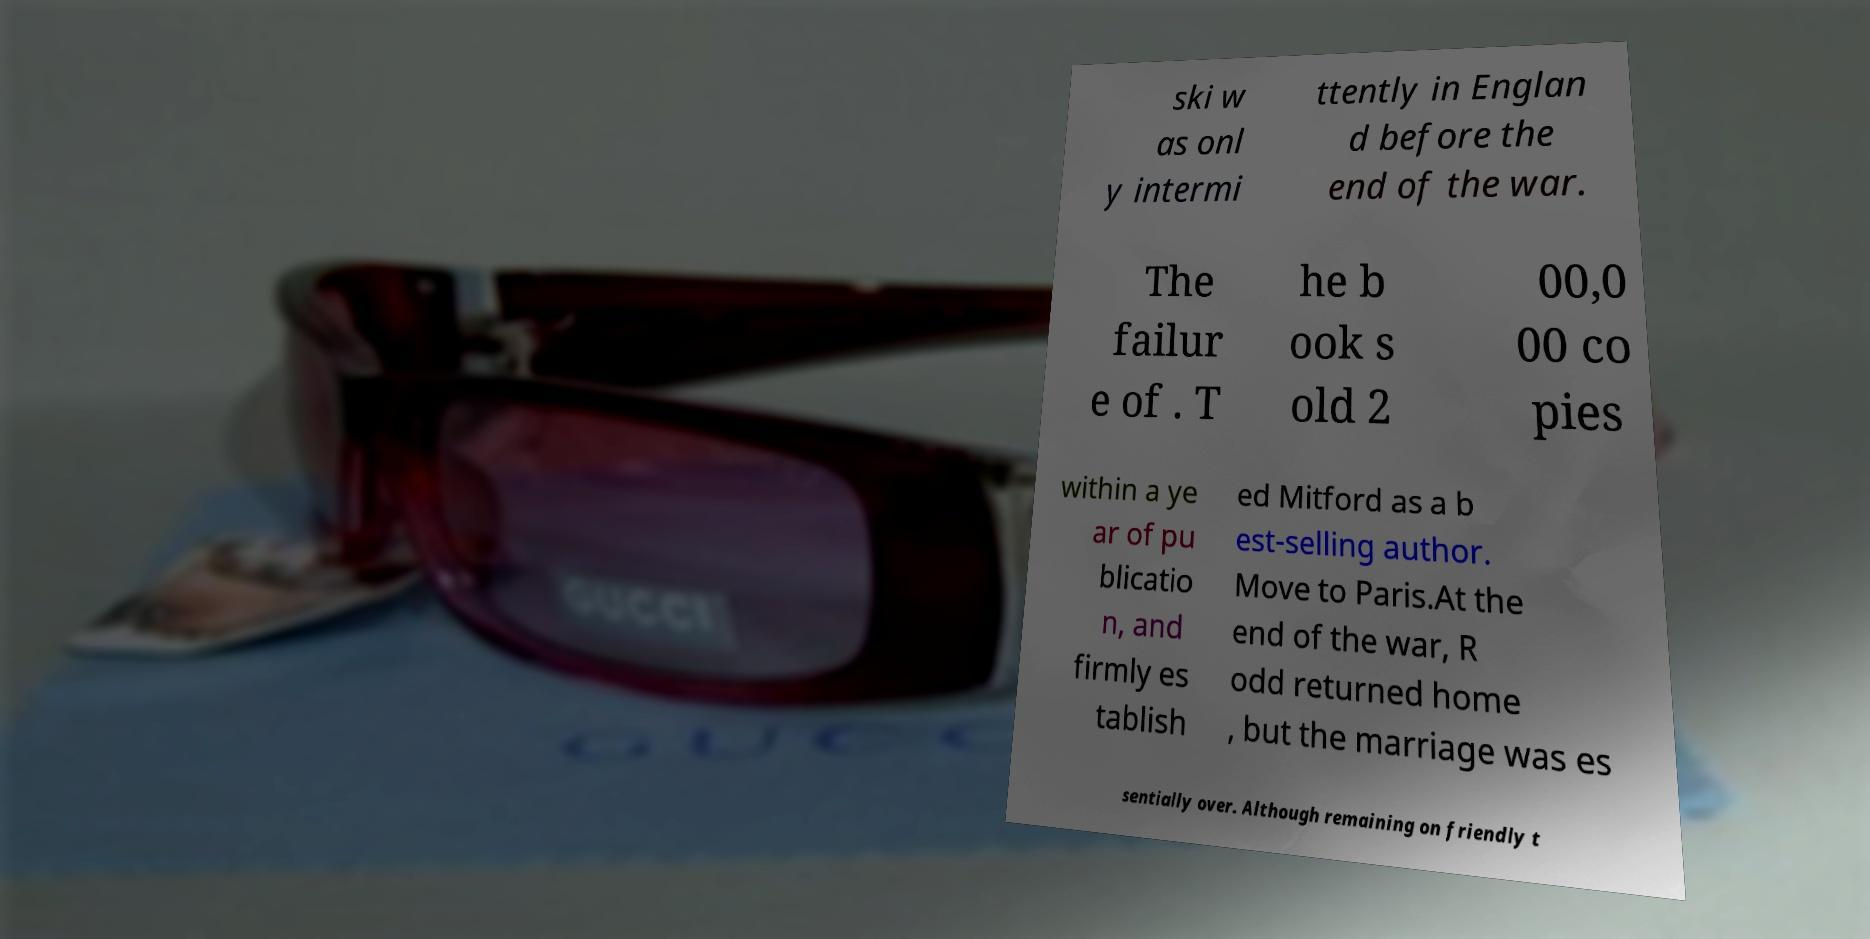Could you extract and type out the text from this image? ski w as onl y intermi ttently in Englan d before the end of the war. The failur e of . T he b ook s old 2 00,0 00 co pies within a ye ar of pu blicatio n, and firmly es tablish ed Mitford as a b est-selling author. Move to Paris.At the end of the war, R odd returned home , but the marriage was es sentially over. Although remaining on friendly t 